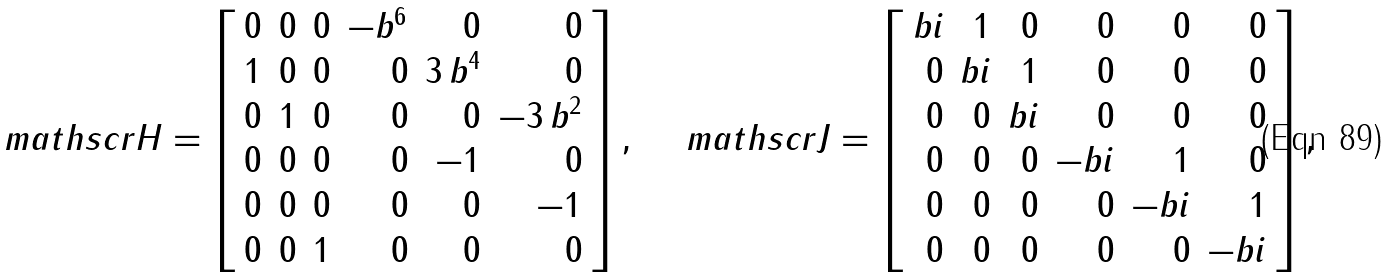Convert formula to latex. <formula><loc_0><loc_0><loc_500><loc_500>\ m a t h s c r { H } = \left [ \begin{array} { r r r r r r } 0 & 0 & 0 & - b ^ { 6 } & 0 & 0 \\ 1 & 0 & 0 & 0 & 3 \, b ^ { 4 } & 0 \\ 0 & 1 & 0 & 0 & 0 & - 3 \, b ^ { 2 } \\ 0 & 0 & 0 & 0 & - 1 & 0 \\ 0 & 0 & 0 & 0 & 0 & - 1 \\ 0 & 0 & 1 & 0 & 0 & 0 \end{array} \right ] , \quad \ m a t h s c r { J } = \left [ \begin{array} { r r r r r r } b i & 1 & 0 & 0 & 0 & 0 \\ 0 & b i & 1 & 0 & 0 & 0 \\ 0 & 0 & b i & 0 & 0 & 0 \\ 0 & 0 & 0 & - b i & 1 & 0 \\ 0 & 0 & 0 & 0 & - b i & 1 \\ 0 & 0 & 0 & 0 & 0 & - b i \end{array} \right ] ,</formula> 